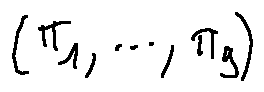Convert formula to latex. <formula><loc_0><loc_0><loc_500><loc_500>( \pi _ { 1 } , \dots , \pi _ { g } )</formula> 